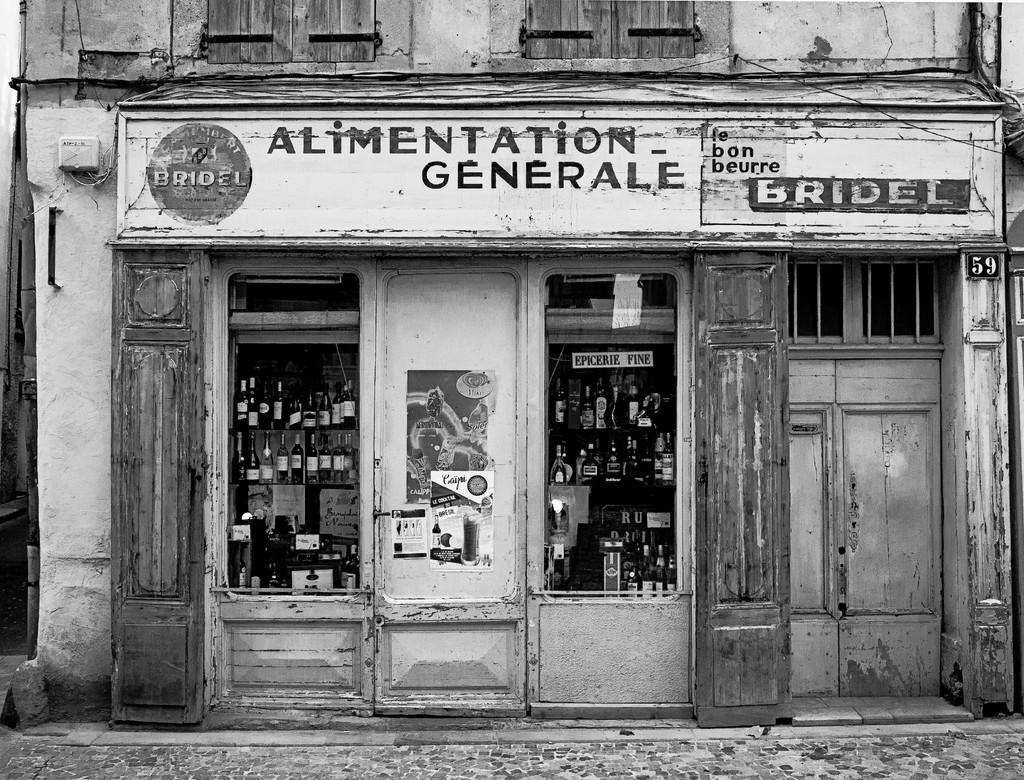What type of path is visible in the image? There is a footpath in the image. What can be seen in the background of the image? There are bottles arranged on shelves, a hoarding, a door, and windows of a building in the background. What type of bean is being used to whistle in the image? There is no bean or whistling activity present in the image. How many bears can be seen in the image? There are no bears present in the image. 